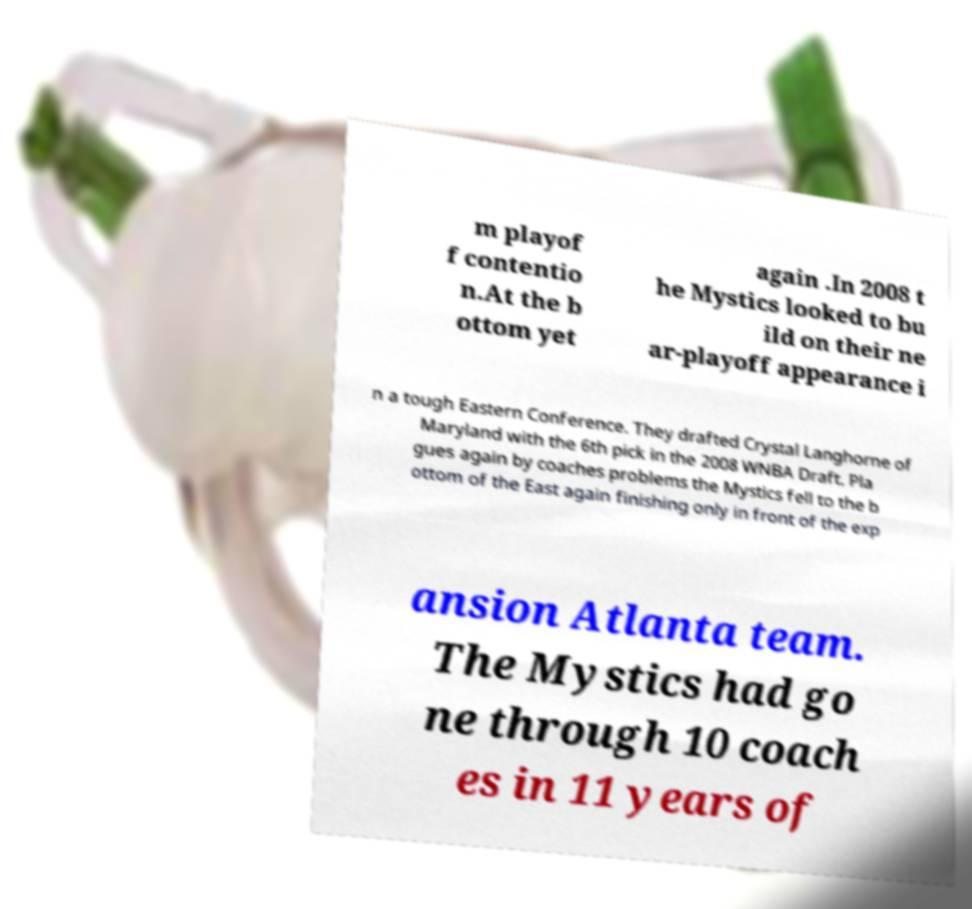There's text embedded in this image that I need extracted. Can you transcribe it verbatim? m playof f contentio n.At the b ottom yet again .In 2008 t he Mystics looked to bu ild on their ne ar-playoff appearance i n a tough Eastern Conference. They drafted Crystal Langhorne of Maryland with the 6th pick in the 2008 WNBA Draft. Pla gues again by coaches problems the Mystics fell to the b ottom of the East again finishing only in front of the exp ansion Atlanta team. The Mystics had go ne through 10 coach es in 11 years of 